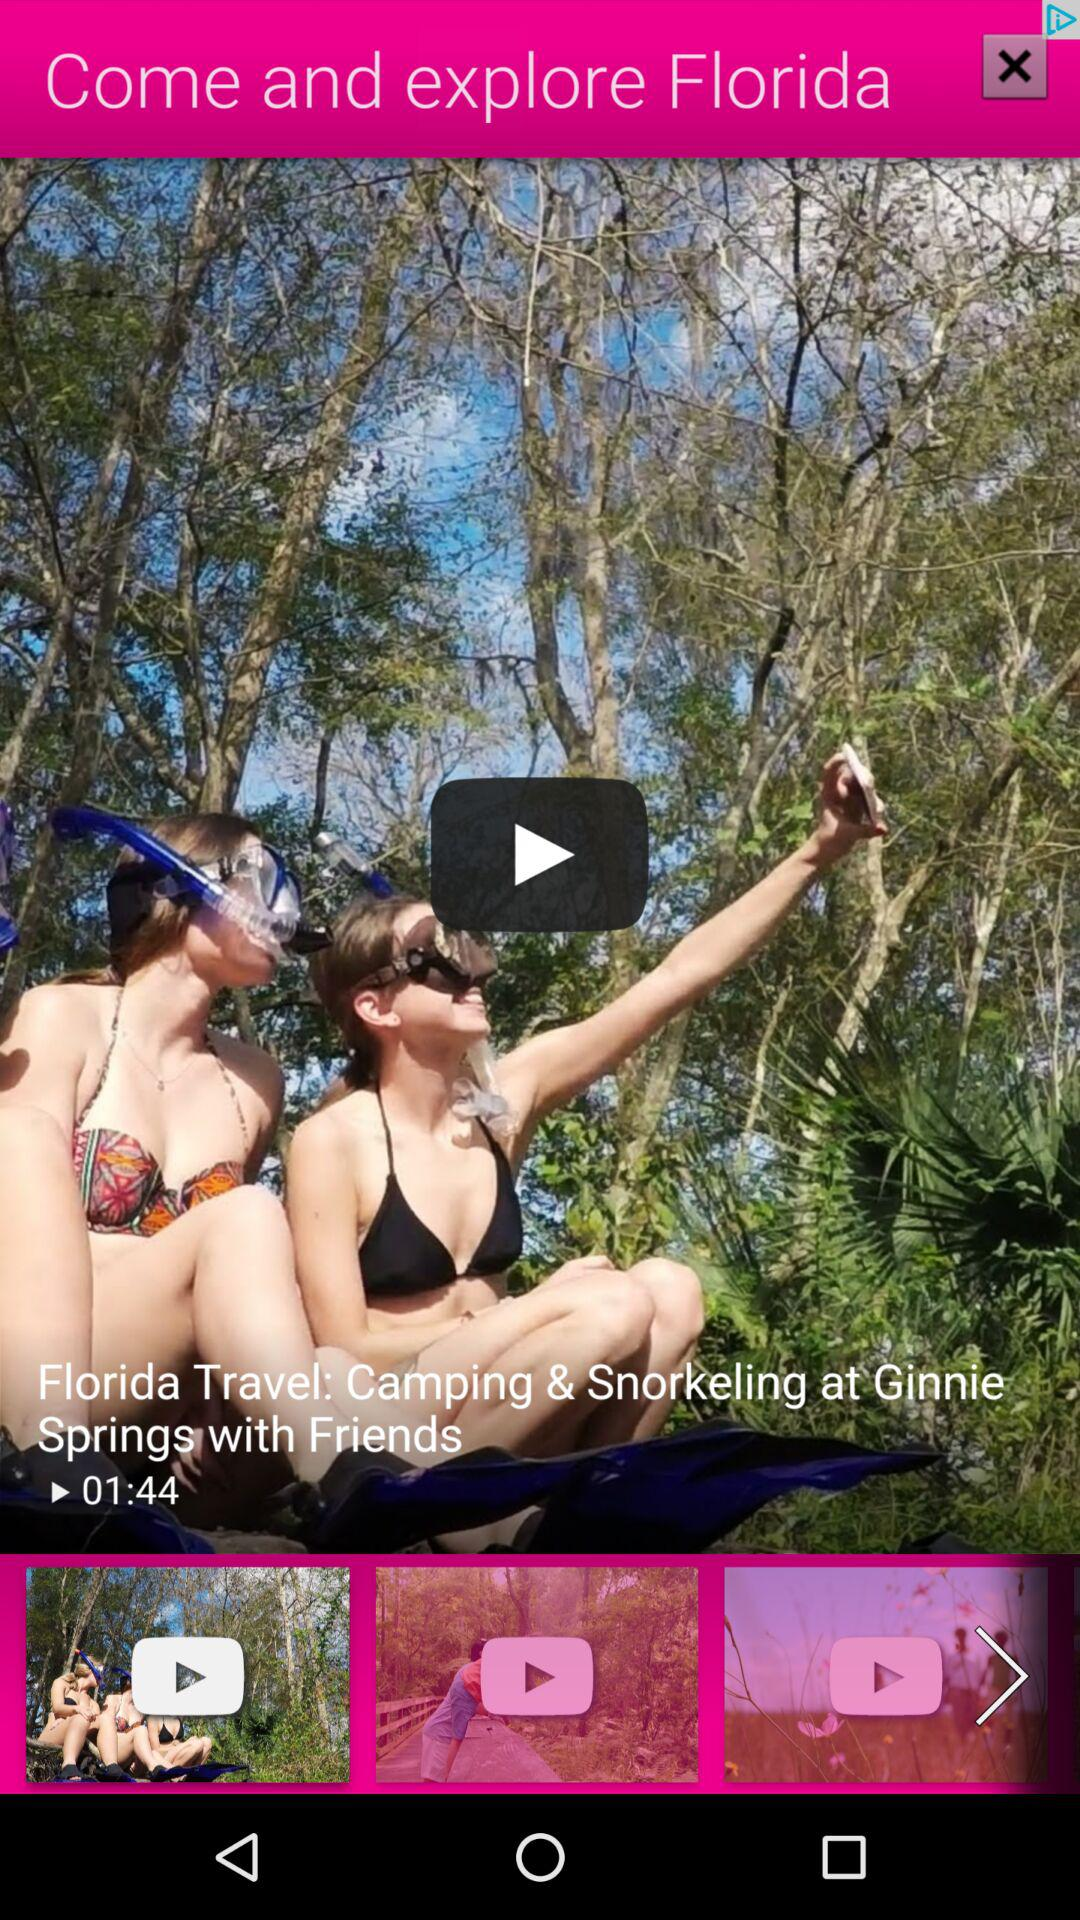How long is the video? The video is 1 minute 44 seconds long. 